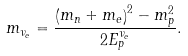<formula> <loc_0><loc_0><loc_500><loc_500>m _ { { \nu } _ { e } } = \frac { \left ( m _ { n } + m _ { e } \right ) ^ { 2 } - m _ { p } ^ { 2 } } { 2 E ^ { { \nu } _ { e } } _ { p } } .</formula> 